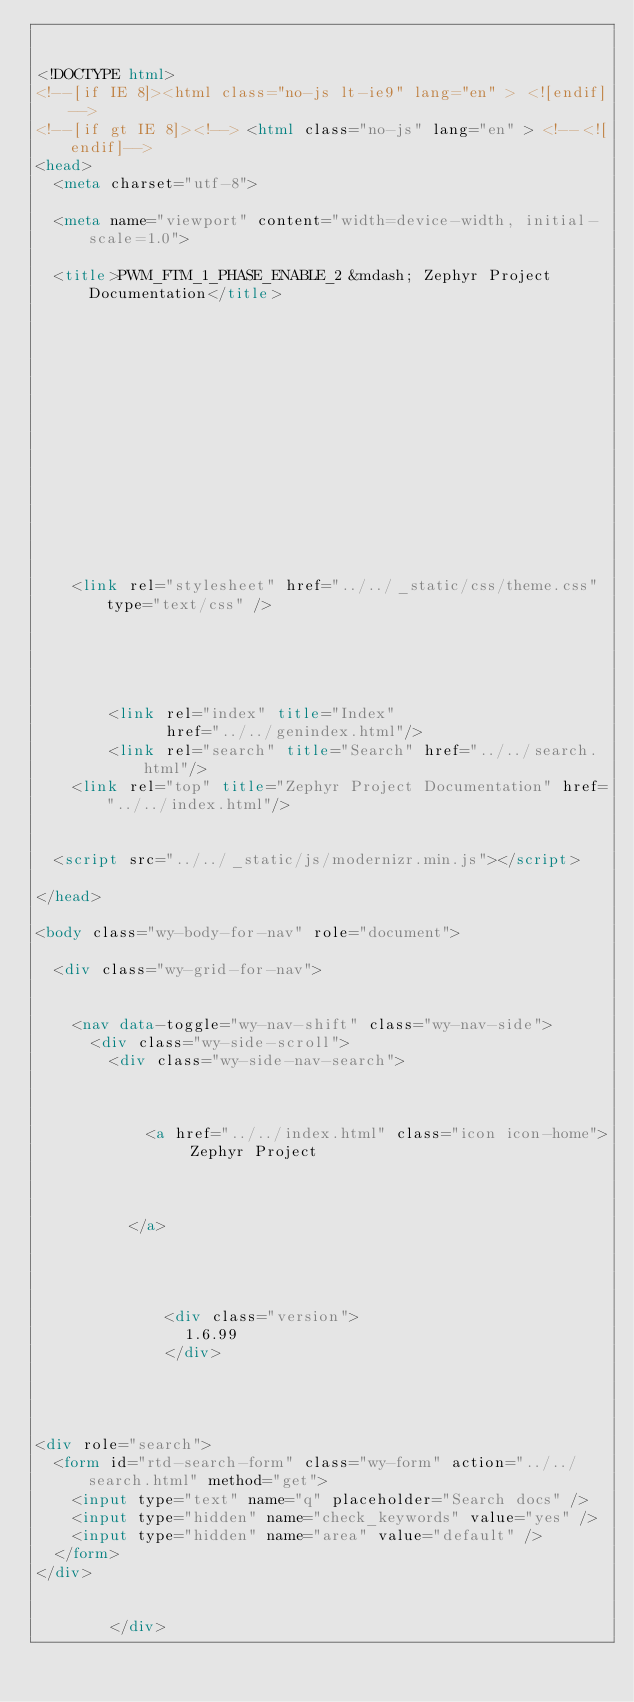<code> <loc_0><loc_0><loc_500><loc_500><_HTML_>

<!DOCTYPE html>
<!--[if IE 8]><html class="no-js lt-ie9" lang="en" > <![endif]-->
<!--[if gt IE 8]><!--> <html class="no-js" lang="en" > <!--<![endif]-->
<head>
  <meta charset="utf-8">
  
  <meta name="viewport" content="width=device-width, initial-scale=1.0">
  
  <title>PWM_FTM_1_PHASE_ENABLE_2 &mdash; Zephyr Project Documentation</title>
  

  
  

  

  
  
    

  

  
  
    <link rel="stylesheet" href="../../_static/css/theme.css" type="text/css" />
  

  

  
        <link rel="index" title="Index"
              href="../../genindex.html"/>
        <link rel="search" title="Search" href="../../search.html"/>
    <link rel="top" title="Zephyr Project Documentation" href="../../index.html"/> 

  
  <script src="../../_static/js/modernizr.min.js"></script>

</head>

<body class="wy-body-for-nav" role="document">

  <div class="wy-grid-for-nav">

    
    <nav data-toggle="wy-nav-shift" class="wy-nav-side">
      <div class="wy-side-scroll">
        <div class="wy-side-nav-search">
          

          
            <a href="../../index.html" class="icon icon-home"> Zephyr Project
          

          
          </a>

          
            
            
              <div class="version">
                1.6.99
              </div>
            
          

          
<div role="search">
  <form id="rtd-search-form" class="wy-form" action="../../search.html" method="get">
    <input type="text" name="q" placeholder="Search docs" />
    <input type="hidden" name="check_keywords" value="yes" />
    <input type="hidden" name="area" value="default" />
  </form>
</div>

          
        </div>
</code> 